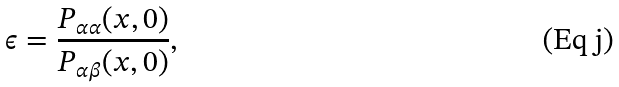<formula> <loc_0><loc_0><loc_500><loc_500>\epsilon = \frac { P _ { \alpha \alpha } ( x , 0 ) } { P _ { \alpha \beta } ( x , 0 ) } ,</formula> 